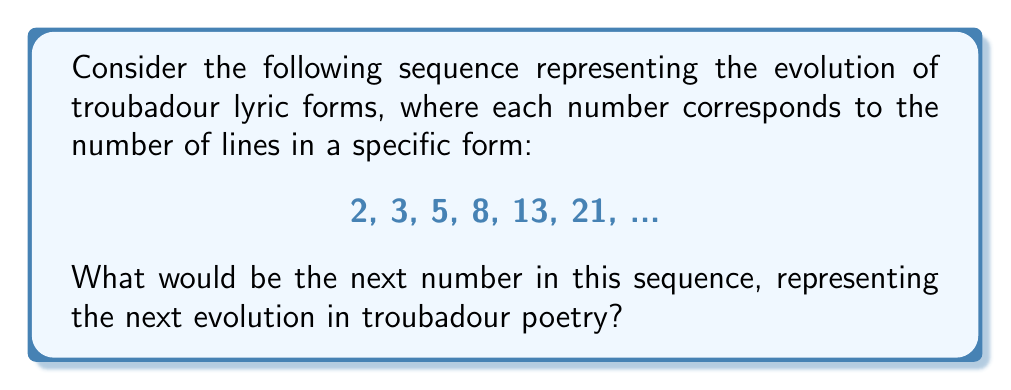Teach me how to tackle this problem. Let's approach this step-by-step:

1) First, let's examine the given sequence: 2, 3, 5, 8, 13, 21, ...

2) To find the pattern, let's look at the differences between consecutive terms:
   3 - 2 = 1
   5 - 3 = 2
   8 - 5 = 3
   13 - 8 = 5
   21 - 13 = 8

3) We notice that each difference is equal to the previous term in the original sequence. This is a key characteristic of the Fibonacci sequence.

4) In the Fibonacci sequence, each number is the sum of the two preceding ones. We can verify this:
   2 + 3 = 5
   3 + 5 = 8
   5 + 8 = 13
   8 + 13 = 21

5) To find the next number, we need to add the last two numbers in the sequence:
   13 + 21 = 34

6) We can express this mathematically as:

   $$F_n = F_{n-1} + F_{n-2}$$

   Where $F_n$ represents the nth term in the Fibonacci sequence.

7) In our case, we're looking for the 7th term, so:

   $$F_7 = F_6 + F_5 = 21 + 13 = 34$$

Therefore, the next number in the sequence, representing the next evolution in troubadour poetry forms, would be 34.
Answer: 34 